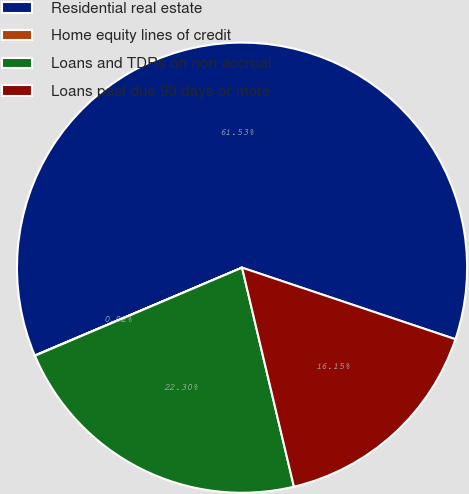Convert chart to OTSL. <chart><loc_0><loc_0><loc_500><loc_500><pie_chart><fcel>Residential real estate<fcel>Home equity lines of credit<fcel>Loans and TDRs on non-accrual<fcel>Loans past due 90 days or more<nl><fcel>61.53%<fcel>0.02%<fcel>22.3%<fcel>16.15%<nl></chart> 